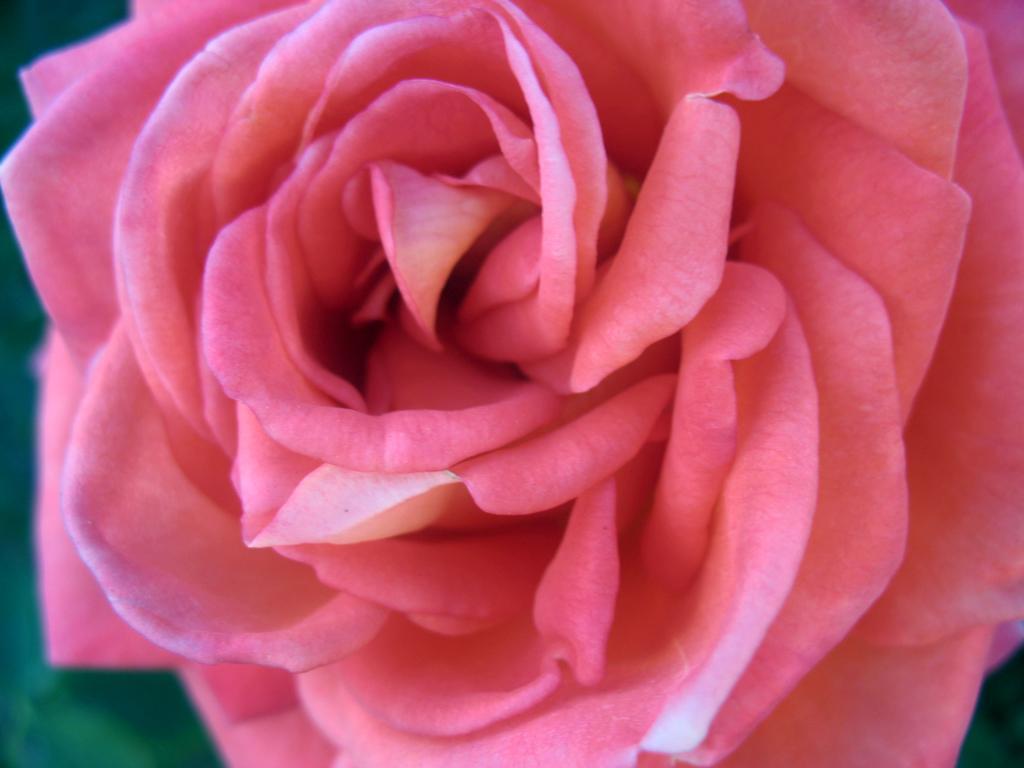How would you summarize this image in a sentence or two? In this image the background is green in color. In the middle of the image there is a beautiful pink rose. 